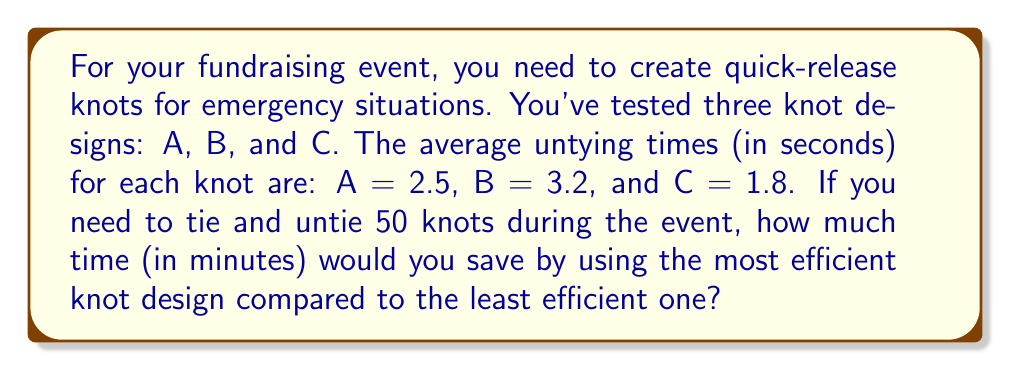Teach me how to tackle this problem. 1. Identify the most and least efficient knots:
   - Knot A: 2.5 seconds
   - Knot B: 3.2 seconds (least efficient)
   - Knot C: 1.8 seconds (most efficient)

2. Calculate the time difference per knot:
   $\text{Time difference} = 3.2 - 1.8 = 1.4 \text{ seconds}$

3. Calculate the total time saved for 50 knots:
   $\text{Total time saved} = 50 \times 1.4 = 70 \text{ seconds}$

4. Convert seconds to minutes:
   $\text{Time saved in minutes} = \frac{70 \text{ seconds}}{60 \text{ seconds/minute}} = \frac{7}{6} \text{ minutes}$

5. Simplify the fraction:
   $\frac{7}{6} = 1\frac{1}{6} \text{ minutes}$
Answer: $1\frac{1}{6} \text{ minutes}$ 